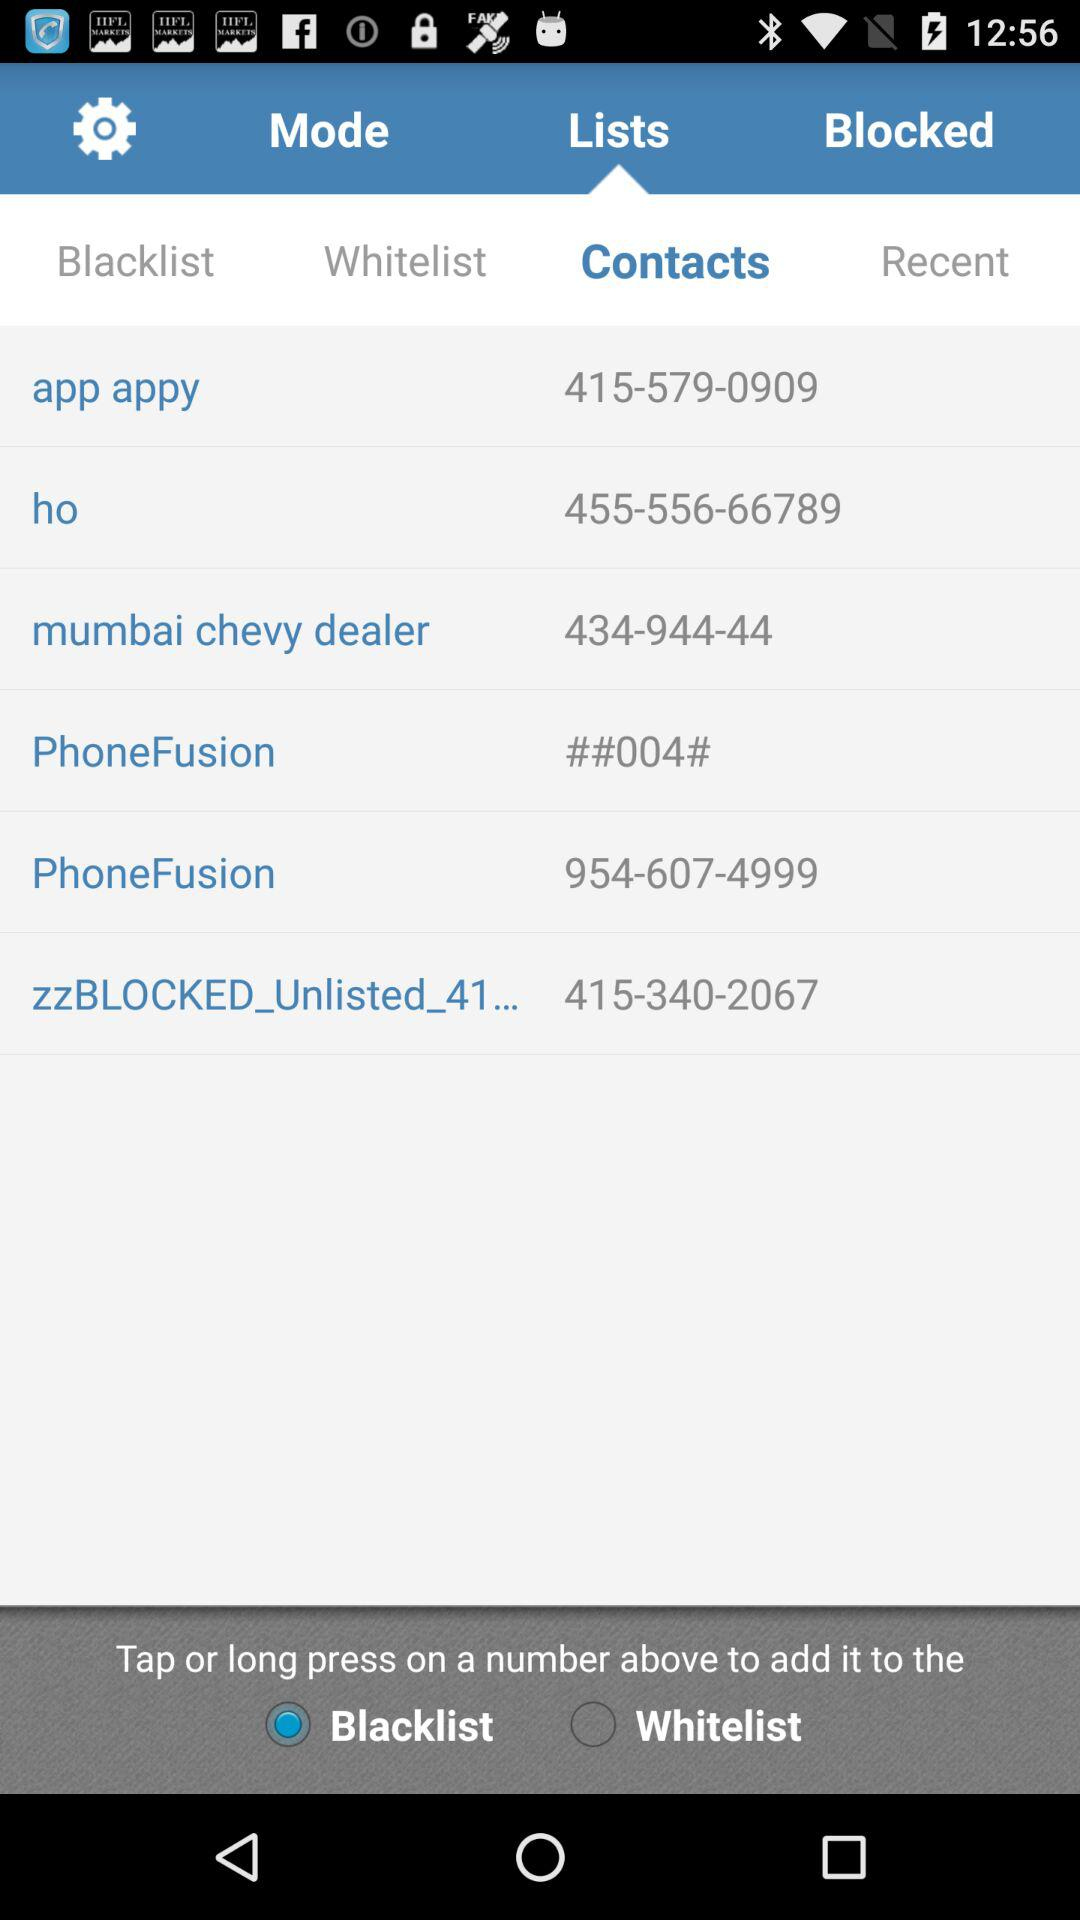What is the contact number of the Mumbai Chevy dealer? The contact number is 434-944-44. 